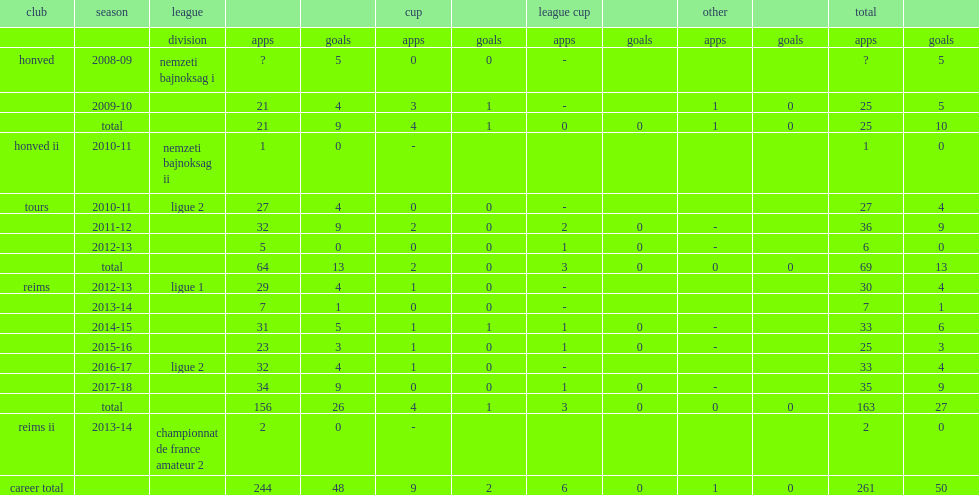In the 2017-18 season, which division did diego appeare with reims in? Ligue 2. Could you parse the entire table? {'header': ['club', 'season', 'league', '', '', 'cup', '', 'league cup', '', 'other', '', 'total', ''], 'rows': [['', '', 'division', 'apps', 'goals', 'apps', 'goals', 'apps', 'goals', 'apps', 'goals', 'apps', 'goals'], ['honved', '2008-09', 'nemzeti bajnoksag i', '?', '5', '0', '0', '-', '', '', '', '?', '5'], ['', '2009-10', '', '21', '4', '3', '1', '-', '', '1', '0', '25', '5'], ['', 'total', '', '21', '9', '4', '1', '0', '0', '1', '0', '25', '10'], ['honved ii', '2010-11', 'nemzeti bajnoksag ii', '1', '0', '-', '', '', '', '', '', '1', '0'], ['tours', '2010-11', 'ligue 2', '27', '4', '0', '0', '-', '', '', '', '27', '4'], ['', '2011-12', '', '32', '9', '2', '0', '2', '0', '-', '', '36', '9'], ['', '2012-13', '', '5', '0', '0', '0', '1', '0', '-', '', '6', '0'], ['', 'total', '', '64', '13', '2', '0', '3', '0', '0', '0', '69', '13'], ['reims', '2012-13', 'ligue 1', '29', '4', '1', '0', '-', '', '', '', '30', '4'], ['', '2013-14', '', '7', '1', '0', '0', '-', '', '', '', '7', '1'], ['', '2014-15', '', '31', '5', '1', '1', '1', '0', '-', '', '33', '6'], ['', '2015-16', '', '23', '3', '1', '0', '1', '0', '-', '', '25', '3'], ['', '2016-17', 'ligue 2', '32', '4', '1', '0', '-', '', '', '', '33', '4'], ['', '2017-18', '', '34', '9', '0', '0', '1', '0', '-', '', '35', '9'], ['', 'total', '', '156', '26', '4', '1', '3', '0', '0', '0', '163', '27'], ['reims ii', '2013-14', 'championnat de france amateur 2', '2', '0', '-', '', '', '', '', '', '2', '0'], ['career total', '', '', '244', '48', '9', '2', '6', '0', '1', '0', '261', '50']]} 